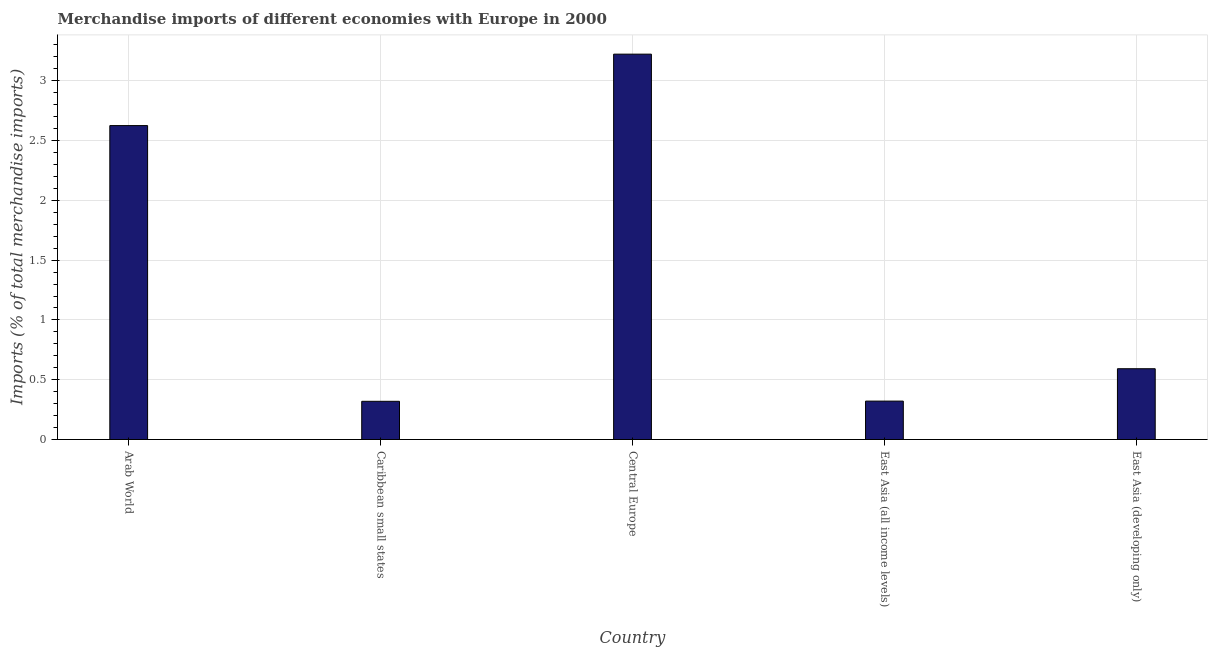Does the graph contain any zero values?
Make the answer very short. No. What is the title of the graph?
Make the answer very short. Merchandise imports of different economies with Europe in 2000. What is the label or title of the Y-axis?
Keep it short and to the point. Imports (% of total merchandise imports). What is the merchandise imports in East Asia (developing only)?
Provide a succinct answer. 0.59. Across all countries, what is the maximum merchandise imports?
Keep it short and to the point. 3.22. Across all countries, what is the minimum merchandise imports?
Keep it short and to the point. 0.32. In which country was the merchandise imports maximum?
Ensure brevity in your answer.  Central Europe. In which country was the merchandise imports minimum?
Keep it short and to the point. Caribbean small states. What is the sum of the merchandise imports?
Make the answer very short. 7.08. What is the difference between the merchandise imports in Caribbean small states and East Asia (all income levels)?
Make the answer very short. -0. What is the average merchandise imports per country?
Your answer should be very brief. 1.42. What is the median merchandise imports?
Provide a short and direct response. 0.59. In how many countries, is the merchandise imports greater than 0.3 %?
Offer a very short reply. 5. What is the ratio of the merchandise imports in Caribbean small states to that in East Asia (developing only)?
Your answer should be very brief. 0.54. Is the merchandise imports in Caribbean small states less than that in East Asia (all income levels)?
Keep it short and to the point. Yes. Is the difference between the merchandise imports in Arab World and Caribbean small states greater than the difference between any two countries?
Keep it short and to the point. No. What is the difference between the highest and the second highest merchandise imports?
Offer a terse response. 0.6. Is the sum of the merchandise imports in Arab World and East Asia (all income levels) greater than the maximum merchandise imports across all countries?
Provide a short and direct response. No. How many bars are there?
Your response must be concise. 5. Are all the bars in the graph horizontal?
Give a very brief answer. No. Are the values on the major ticks of Y-axis written in scientific E-notation?
Provide a short and direct response. No. What is the Imports (% of total merchandise imports) of Arab World?
Your response must be concise. 2.63. What is the Imports (% of total merchandise imports) of Caribbean small states?
Make the answer very short. 0.32. What is the Imports (% of total merchandise imports) in Central Europe?
Your answer should be compact. 3.22. What is the Imports (% of total merchandise imports) in East Asia (all income levels)?
Your answer should be very brief. 0.32. What is the Imports (% of total merchandise imports) in East Asia (developing only)?
Offer a very short reply. 0.59. What is the difference between the Imports (% of total merchandise imports) in Arab World and Caribbean small states?
Your response must be concise. 2.31. What is the difference between the Imports (% of total merchandise imports) in Arab World and Central Europe?
Make the answer very short. -0.6. What is the difference between the Imports (% of total merchandise imports) in Arab World and East Asia (all income levels)?
Provide a short and direct response. 2.3. What is the difference between the Imports (% of total merchandise imports) in Arab World and East Asia (developing only)?
Ensure brevity in your answer.  2.03. What is the difference between the Imports (% of total merchandise imports) in Caribbean small states and Central Europe?
Provide a succinct answer. -2.9. What is the difference between the Imports (% of total merchandise imports) in Caribbean small states and East Asia (all income levels)?
Make the answer very short. -0. What is the difference between the Imports (% of total merchandise imports) in Caribbean small states and East Asia (developing only)?
Make the answer very short. -0.27. What is the difference between the Imports (% of total merchandise imports) in Central Europe and East Asia (all income levels)?
Keep it short and to the point. 2.9. What is the difference between the Imports (% of total merchandise imports) in Central Europe and East Asia (developing only)?
Ensure brevity in your answer.  2.63. What is the difference between the Imports (% of total merchandise imports) in East Asia (all income levels) and East Asia (developing only)?
Your answer should be compact. -0.27. What is the ratio of the Imports (% of total merchandise imports) in Arab World to that in Caribbean small states?
Provide a succinct answer. 8.21. What is the ratio of the Imports (% of total merchandise imports) in Arab World to that in Central Europe?
Offer a terse response. 0.81. What is the ratio of the Imports (% of total merchandise imports) in Arab World to that in East Asia (all income levels)?
Ensure brevity in your answer.  8.17. What is the ratio of the Imports (% of total merchandise imports) in Arab World to that in East Asia (developing only)?
Give a very brief answer. 4.43. What is the ratio of the Imports (% of total merchandise imports) in Caribbean small states to that in Central Europe?
Make the answer very short. 0.1. What is the ratio of the Imports (% of total merchandise imports) in Caribbean small states to that in East Asia (developing only)?
Offer a very short reply. 0.54. What is the ratio of the Imports (% of total merchandise imports) in Central Europe to that in East Asia (all income levels)?
Ensure brevity in your answer.  10.03. What is the ratio of the Imports (% of total merchandise imports) in Central Europe to that in East Asia (developing only)?
Make the answer very short. 5.44. What is the ratio of the Imports (% of total merchandise imports) in East Asia (all income levels) to that in East Asia (developing only)?
Ensure brevity in your answer.  0.54. 